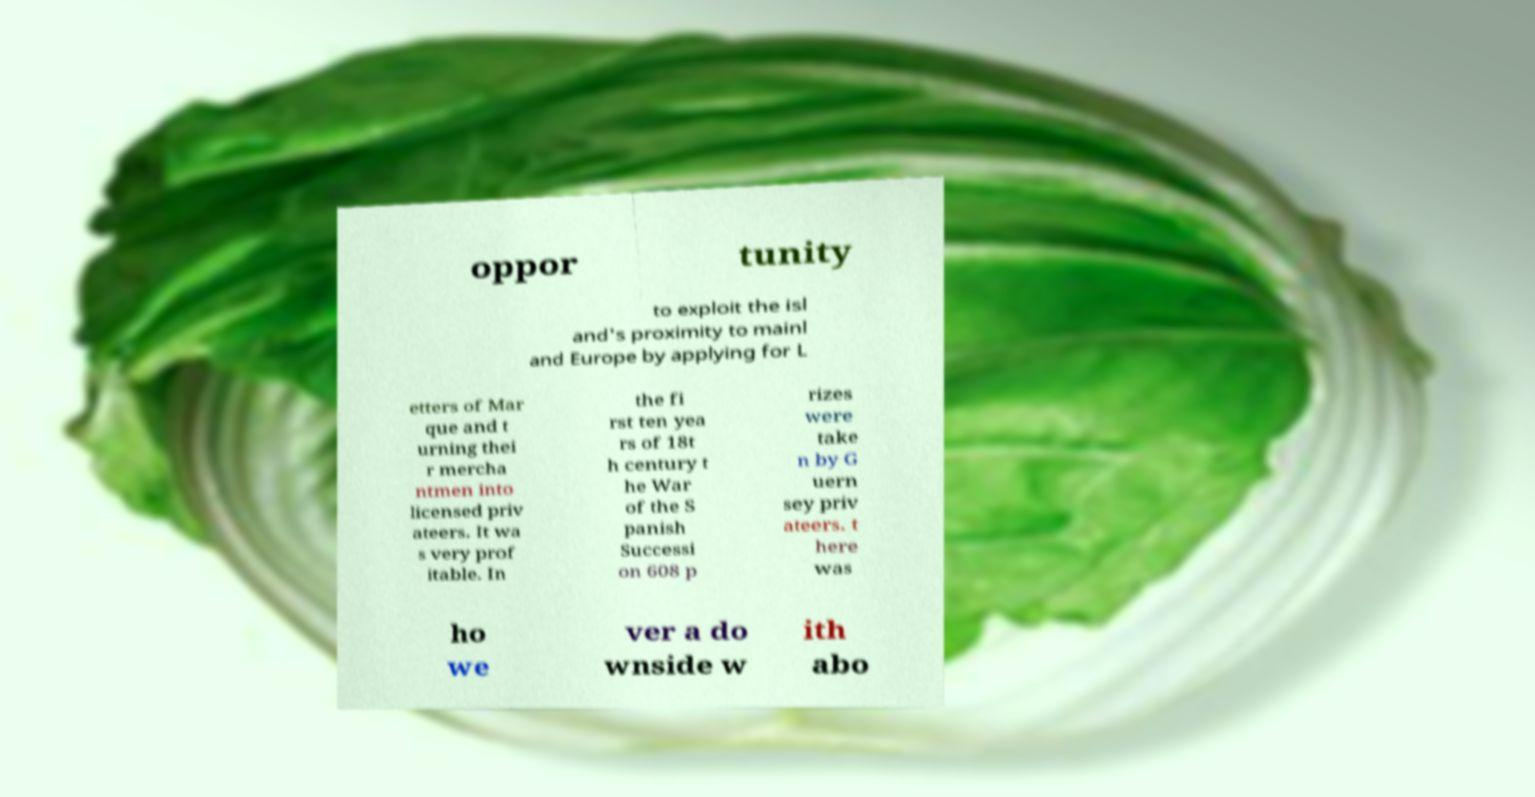I need the written content from this picture converted into text. Can you do that? oppor tunity to exploit the isl and's proximity to mainl and Europe by applying for L etters of Mar que and t urning thei r mercha ntmen into licensed priv ateers. It wa s very prof itable. In the fi rst ten yea rs of 18t h century t he War of the S panish Successi on 608 p rizes were take n by G uern sey priv ateers. t here was ho we ver a do wnside w ith abo 